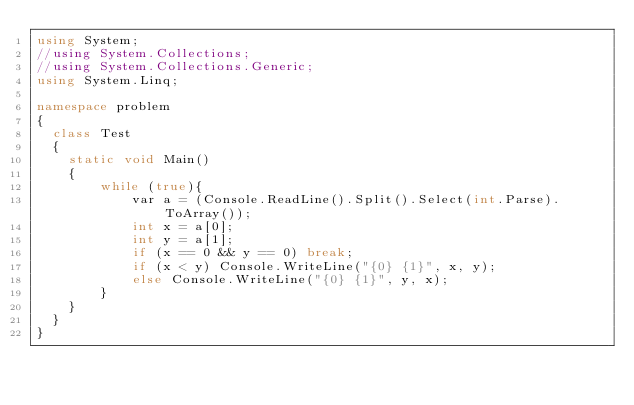Convert code to text. <code><loc_0><loc_0><loc_500><loc_500><_C#_>using System;
//using System.Collections;
//using System.Collections.Generic;
using System.Linq;

namespace problem
{
  class Test
  {
    static void Main()
    {
        while (true){
            var a = (Console.ReadLine().Split().Select(int.Parse).ToArray());
            int x = a[0];
            int y = a[1];
            if (x == 0 && y == 0) break;
            if (x < y) Console.WriteLine("{0} {1}", x, y);
            else Console.WriteLine("{0} {1}", y, x);
        }
    }
  }
}
</code> 